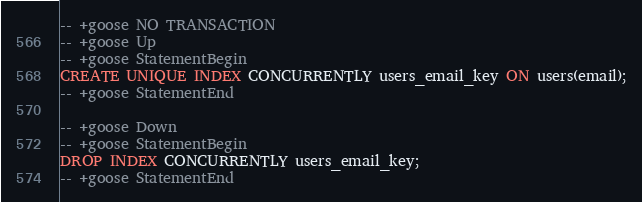<code> <loc_0><loc_0><loc_500><loc_500><_SQL_>-- +goose NO TRANSACTION
-- +goose Up
-- +goose StatementBegin
CREATE UNIQUE INDEX CONCURRENTLY users_email_key ON users(email);
-- +goose StatementEnd

-- +goose Down
-- +goose StatementBegin
DROP INDEX CONCURRENTLY users_email_key;
-- +goose StatementEnd
</code> 